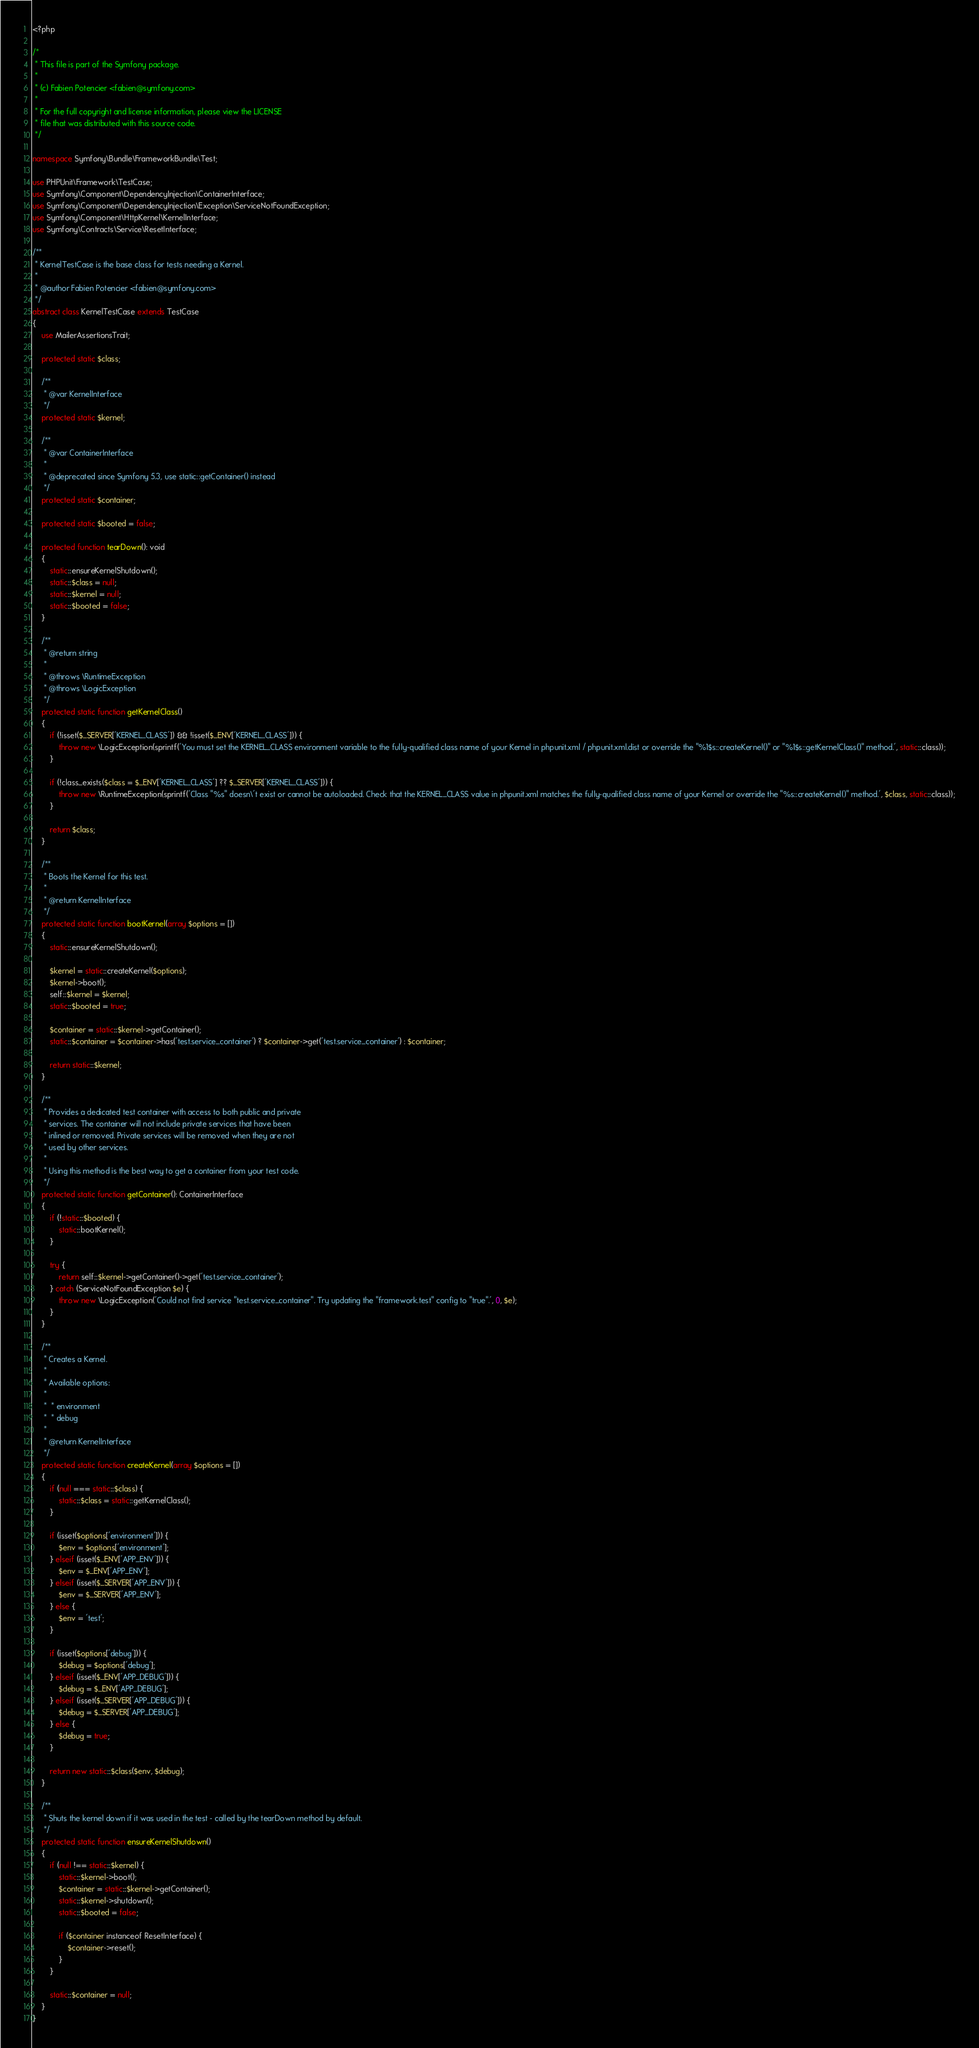Convert code to text. <code><loc_0><loc_0><loc_500><loc_500><_PHP_><?php

/*
 * This file is part of the Symfony package.
 *
 * (c) Fabien Potencier <fabien@symfony.com>
 *
 * For the full copyright and license information, please view the LICENSE
 * file that was distributed with this source code.
 */

namespace Symfony\Bundle\FrameworkBundle\Test;

use PHPUnit\Framework\TestCase;
use Symfony\Component\DependencyInjection\ContainerInterface;
use Symfony\Component\DependencyInjection\Exception\ServiceNotFoundException;
use Symfony\Component\HttpKernel\KernelInterface;
use Symfony\Contracts\Service\ResetInterface;

/**
 * KernelTestCase is the base class for tests needing a Kernel.
 *
 * @author Fabien Potencier <fabien@symfony.com>
 */
abstract class KernelTestCase extends TestCase
{
    use MailerAssertionsTrait;

    protected static $class;

    /**
     * @var KernelInterface
     */
    protected static $kernel;

    /**
     * @var ContainerInterface
     *
     * @deprecated since Symfony 5.3, use static::getContainer() instead
     */
    protected static $container;

    protected static $booted = false;

    protected function tearDown(): void
    {
        static::ensureKernelShutdown();
        static::$class = null;
        static::$kernel = null;
        static::$booted = false;
    }

    /**
     * @return string
     *
     * @throws \RuntimeException
     * @throws \LogicException
     */
    protected static function getKernelClass()
    {
        if (!isset($_SERVER['KERNEL_CLASS']) && !isset($_ENV['KERNEL_CLASS'])) {
            throw new \LogicException(sprintf('You must set the KERNEL_CLASS environment variable to the fully-qualified class name of your Kernel in phpunit.xml / phpunit.xml.dist or override the "%1$s::createKernel()" or "%1$s::getKernelClass()" method.', static::class));
        }

        if (!class_exists($class = $_ENV['KERNEL_CLASS'] ?? $_SERVER['KERNEL_CLASS'])) {
            throw new \RuntimeException(sprintf('Class "%s" doesn\'t exist or cannot be autoloaded. Check that the KERNEL_CLASS value in phpunit.xml matches the fully-qualified class name of your Kernel or override the "%s::createKernel()" method.', $class, static::class));
        }

        return $class;
    }

    /**
     * Boots the Kernel for this test.
     *
     * @return KernelInterface
     */
    protected static function bootKernel(array $options = [])
    {
        static::ensureKernelShutdown();

        $kernel = static::createKernel($options);
        $kernel->boot();
        self::$kernel = $kernel;
        static::$booted = true;

        $container = static::$kernel->getContainer();
        static::$container = $container->has('test.service_container') ? $container->get('test.service_container') : $container;

        return static::$kernel;
    }

    /**
     * Provides a dedicated test container with access to both public and private
     * services. The container will not include private services that have been
     * inlined or removed. Private services will be removed when they are not
     * used by other services.
     *
     * Using this method is the best way to get a container from your test code.
     */
    protected static function getContainer(): ContainerInterface
    {
        if (!static::$booted) {
            static::bootKernel();
        }

        try {
            return self::$kernel->getContainer()->get('test.service_container');
        } catch (ServiceNotFoundException $e) {
            throw new \LogicException('Could not find service "test.service_container". Try updating the "framework.test" config to "true".', 0, $e);
        }
    }

    /**
     * Creates a Kernel.
     *
     * Available options:
     *
     *  * environment
     *  * debug
     *
     * @return KernelInterface
     */
    protected static function createKernel(array $options = [])
    {
        if (null === static::$class) {
            static::$class = static::getKernelClass();
        }

        if (isset($options['environment'])) {
            $env = $options['environment'];
        } elseif (isset($_ENV['APP_ENV'])) {
            $env = $_ENV['APP_ENV'];
        } elseif (isset($_SERVER['APP_ENV'])) {
            $env = $_SERVER['APP_ENV'];
        } else {
            $env = 'test';
        }

        if (isset($options['debug'])) {
            $debug = $options['debug'];
        } elseif (isset($_ENV['APP_DEBUG'])) {
            $debug = $_ENV['APP_DEBUG'];
        } elseif (isset($_SERVER['APP_DEBUG'])) {
            $debug = $_SERVER['APP_DEBUG'];
        } else {
            $debug = true;
        }

        return new static::$class($env, $debug);
    }

    /**
     * Shuts the kernel down if it was used in the test - called by the tearDown method by default.
     */
    protected static function ensureKernelShutdown()
    {
        if (null !== static::$kernel) {
            static::$kernel->boot();
            $container = static::$kernel->getContainer();
            static::$kernel->shutdown();
            static::$booted = false;

            if ($container instanceof ResetInterface) {
                $container->reset();
            }
        }

        static::$container = null;
    }
}
</code> 